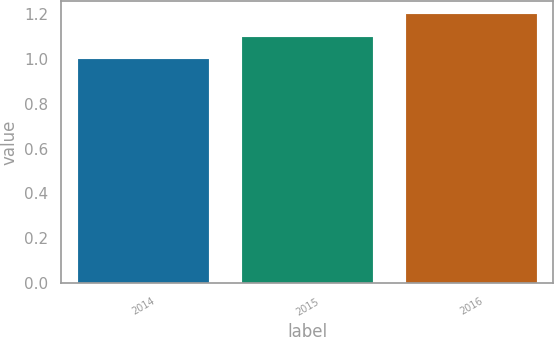Convert chart. <chart><loc_0><loc_0><loc_500><loc_500><bar_chart><fcel>2014<fcel>2015<fcel>2016<nl><fcel>1<fcel>1.1<fcel>1.2<nl></chart> 